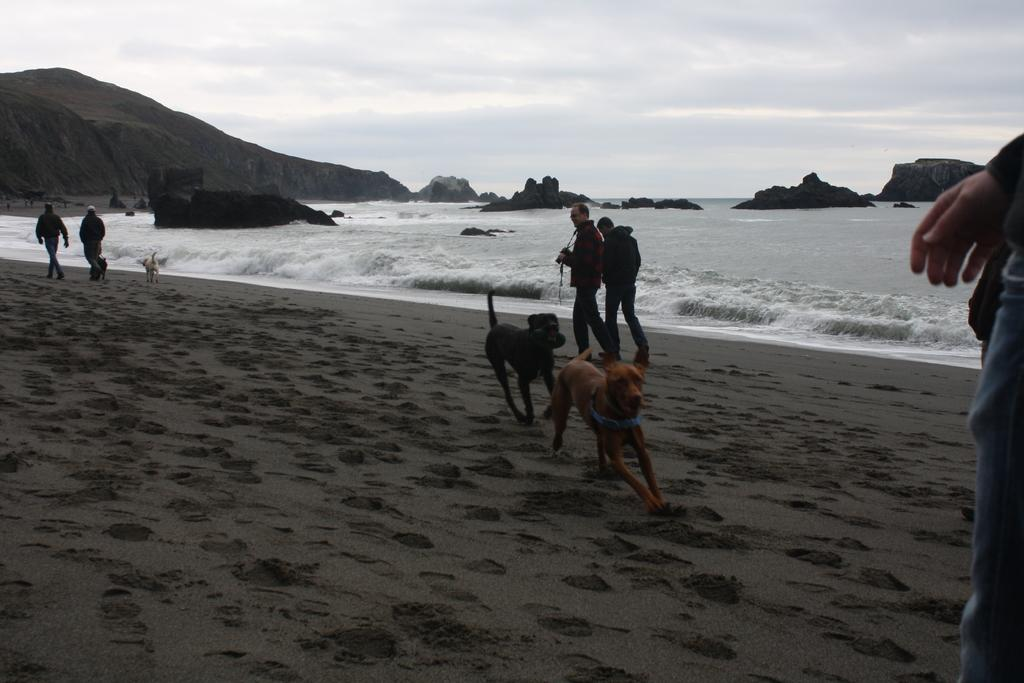What animals can be seen in the foreground of the image? There are three dogs in the foreground of the image. What is the setting of the image? The image is likely taken near the ocean, as there are people on the beach and water visible in the background. What geographical features can be seen in the background of the image? There are mountains and water visible in the background of the image. What part of the natural environment is visible in the background of the image? The sky is visible in the background of the image. What type of thought can be seen in the image? There is no thought visible in the image; it is a photograph of a scene with dogs, people, and a beach. Can you tell me where the library is located in the image? There is no library present in the image. 